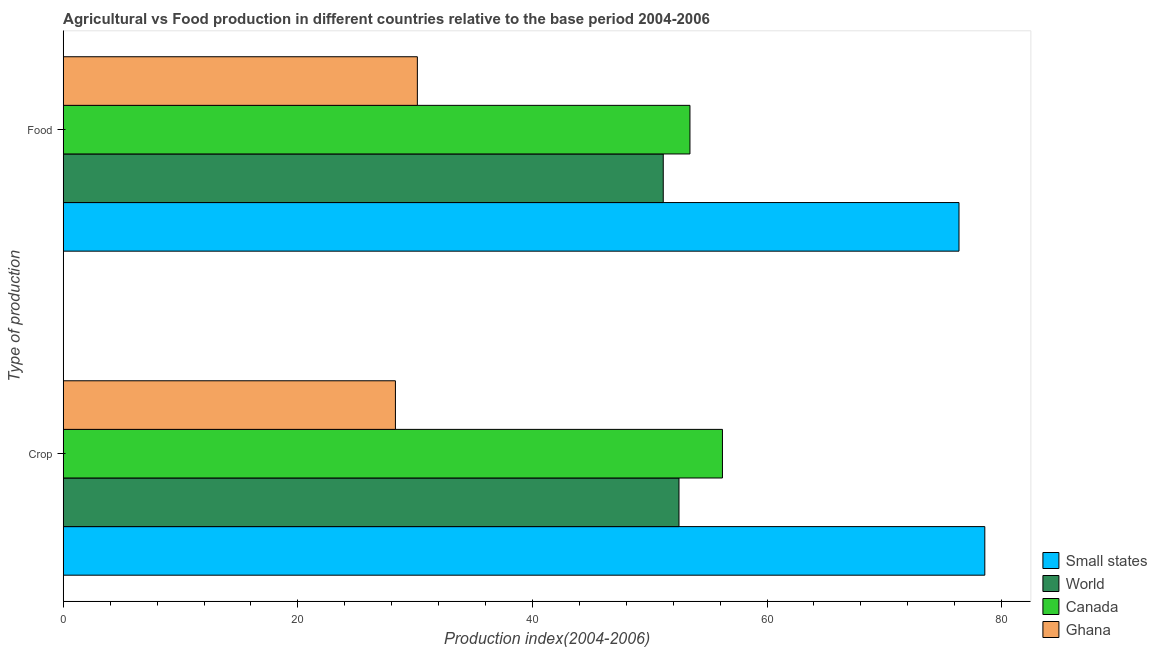How many different coloured bars are there?
Give a very brief answer. 4. How many bars are there on the 2nd tick from the bottom?
Offer a very short reply. 4. What is the label of the 1st group of bars from the top?
Provide a short and direct response. Food. What is the food production index in Ghana?
Offer a very short reply. 30.19. Across all countries, what is the maximum crop production index?
Make the answer very short. 78.57. Across all countries, what is the minimum food production index?
Your response must be concise. 30.19. In which country was the food production index maximum?
Provide a succinct answer. Small states. In which country was the crop production index minimum?
Your response must be concise. Ghana. What is the total crop production index in the graph?
Your answer should be very brief. 215.58. What is the difference between the food production index in Small states and that in Canada?
Your answer should be compact. 22.94. What is the difference between the crop production index in World and the food production index in Ghana?
Your answer should be very brief. 22.3. What is the average food production index per country?
Your answer should be compact. 52.78. What is the difference between the food production index and crop production index in World?
Ensure brevity in your answer.  -1.34. What is the ratio of the crop production index in Canada to that in Small states?
Your answer should be very brief. 0.72. Is the crop production index in World less than that in Canada?
Provide a short and direct response. Yes. In how many countries, is the crop production index greater than the average crop production index taken over all countries?
Your answer should be very brief. 2. What does the 1st bar from the top in Food represents?
Provide a succinct answer. Ghana. Are all the bars in the graph horizontal?
Keep it short and to the point. Yes. Are the values on the major ticks of X-axis written in scientific E-notation?
Offer a very short reply. No. What is the title of the graph?
Offer a very short reply. Agricultural vs Food production in different countries relative to the base period 2004-2006. Does "Comoros" appear as one of the legend labels in the graph?
Ensure brevity in your answer.  No. What is the label or title of the X-axis?
Offer a very short reply. Production index(2004-2006). What is the label or title of the Y-axis?
Ensure brevity in your answer.  Type of production. What is the Production index(2004-2006) of Small states in Crop?
Ensure brevity in your answer.  78.57. What is the Production index(2004-2006) of World in Crop?
Give a very brief answer. 52.49. What is the Production index(2004-2006) of Canada in Crop?
Your answer should be compact. 56.2. What is the Production index(2004-2006) of Ghana in Crop?
Offer a terse response. 28.32. What is the Production index(2004-2006) of Small states in Food?
Your answer should be compact. 76.37. What is the Production index(2004-2006) in World in Food?
Your answer should be compact. 51.15. What is the Production index(2004-2006) of Canada in Food?
Give a very brief answer. 53.43. What is the Production index(2004-2006) in Ghana in Food?
Offer a very short reply. 30.19. Across all Type of production, what is the maximum Production index(2004-2006) in Small states?
Make the answer very short. 78.57. Across all Type of production, what is the maximum Production index(2004-2006) of World?
Keep it short and to the point. 52.49. Across all Type of production, what is the maximum Production index(2004-2006) of Canada?
Give a very brief answer. 56.2. Across all Type of production, what is the maximum Production index(2004-2006) in Ghana?
Your response must be concise. 30.19. Across all Type of production, what is the minimum Production index(2004-2006) in Small states?
Provide a succinct answer. 76.37. Across all Type of production, what is the minimum Production index(2004-2006) in World?
Give a very brief answer. 51.15. Across all Type of production, what is the minimum Production index(2004-2006) in Canada?
Your answer should be compact. 53.43. Across all Type of production, what is the minimum Production index(2004-2006) of Ghana?
Provide a short and direct response. 28.32. What is the total Production index(2004-2006) in Small states in the graph?
Give a very brief answer. 154.93. What is the total Production index(2004-2006) of World in the graph?
Offer a very short reply. 103.65. What is the total Production index(2004-2006) of Canada in the graph?
Your answer should be compact. 109.63. What is the total Production index(2004-2006) in Ghana in the graph?
Your response must be concise. 58.51. What is the difference between the Production index(2004-2006) in Small states in Crop and that in Food?
Keep it short and to the point. 2.2. What is the difference between the Production index(2004-2006) of World in Crop and that in Food?
Provide a succinct answer. 1.34. What is the difference between the Production index(2004-2006) of Canada in Crop and that in Food?
Your response must be concise. 2.77. What is the difference between the Production index(2004-2006) in Ghana in Crop and that in Food?
Your answer should be very brief. -1.87. What is the difference between the Production index(2004-2006) of Small states in Crop and the Production index(2004-2006) of World in Food?
Your answer should be compact. 27.42. What is the difference between the Production index(2004-2006) in Small states in Crop and the Production index(2004-2006) in Canada in Food?
Make the answer very short. 25.14. What is the difference between the Production index(2004-2006) of Small states in Crop and the Production index(2004-2006) of Ghana in Food?
Offer a terse response. 48.38. What is the difference between the Production index(2004-2006) in World in Crop and the Production index(2004-2006) in Canada in Food?
Ensure brevity in your answer.  -0.94. What is the difference between the Production index(2004-2006) in World in Crop and the Production index(2004-2006) in Ghana in Food?
Give a very brief answer. 22.3. What is the difference between the Production index(2004-2006) in Canada in Crop and the Production index(2004-2006) in Ghana in Food?
Offer a terse response. 26.01. What is the average Production index(2004-2006) in Small states per Type of production?
Your answer should be very brief. 77.47. What is the average Production index(2004-2006) of World per Type of production?
Offer a terse response. 51.82. What is the average Production index(2004-2006) in Canada per Type of production?
Ensure brevity in your answer.  54.81. What is the average Production index(2004-2006) in Ghana per Type of production?
Provide a succinct answer. 29.25. What is the difference between the Production index(2004-2006) in Small states and Production index(2004-2006) in World in Crop?
Provide a succinct answer. 26.07. What is the difference between the Production index(2004-2006) in Small states and Production index(2004-2006) in Canada in Crop?
Provide a succinct answer. 22.37. What is the difference between the Production index(2004-2006) in Small states and Production index(2004-2006) in Ghana in Crop?
Your response must be concise. 50.25. What is the difference between the Production index(2004-2006) of World and Production index(2004-2006) of Canada in Crop?
Keep it short and to the point. -3.71. What is the difference between the Production index(2004-2006) in World and Production index(2004-2006) in Ghana in Crop?
Give a very brief answer. 24.17. What is the difference between the Production index(2004-2006) in Canada and Production index(2004-2006) in Ghana in Crop?
Offer a terse response. 27.88. What is the difference between the Production index(2004-2006) of Small states and Production index(2004-2006) of World in Food?
Your response must be concise. 25.21. What is the difference between the Production index(2004-2006) in Small states and Production index(2004-2006) in Canada in Food?
Your response must be concise. 22.94. What is the difference between the Production index(2004-2006) in Small states and Production index(2004-2006) in Ghana in Food?
Your response must be concise. 46.18. What is the difference between the Production index(2004-2006) in World and Production index(2004-2006) in Canada in Food?
Offer a terse response. -2.28. What is the difference between the Production index(2004-2006) of World and Production index(2004-2006) of Ghana in Food?
Provide a succinct answer. 20.96. What is the difference between the Production index(2004-2006) in Canada and Production index(2004-2006) in Ghana in Food?
Make the answer very short. 23.24. What is the ratio of the Production index(2004-2006) of Small states in Crop to that in Food?
Offer a terse response. 1.03. What is the ratio of the Production index(2004-2006) in World in Crop to that in Food?
Offer a very short reply. 1.03. What is the ratio of the Production index(2004-2006) in Canada in Crop to that in Food?
Your response must be concise. 1.05. What is the ratio of the Production index(2004-2006) of Ghana in Crop to that in Food?
Keep it short and to the point. 0.94. What is the difference between the highest and the second highest Production index(2004-2006) of Small states?
Ensure brevity in your answer.  2.2. What is the difference between the highest and the second highest Production index(2004-2006) in World?
Your answer should be compact. 1.34. What is the difference between the highest and the second highest Production index(2004-2006) of Canada?
Your answer should be compact. 2.77. What is the difference between the highest and the second highest Production index(2004-2006) of Ghana?
Offer a terse response. 1.87. What is the difference between the highest and the lowest Production index(2004-2006) in Small states?
Your response must be concise. 2.2. What is the difference between the highest and the lowest Production index(2004-2006) of World?
Your answer should be very brief. 1.34. What is the difference between the highest and the lowest Production index(2004-2006) of Canada?
Offer a terse response. 2.77. What is the difference between the highest and the lowest Production index(2004-2006) of Ghana?
Offer a terse response. 1.87. 